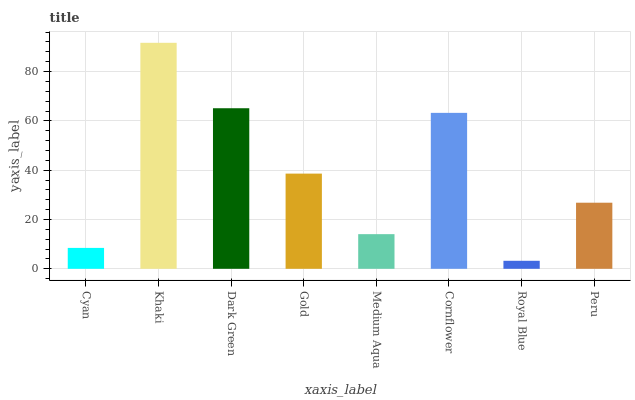Is Royal Blue the minimum?
Answer yes or no. Yes. Is Khaki the maximum?
Answer yes or no. Yes. Is Dark Green the minimum?
Answer yes or no. No. Is Dark Green the maximum?
Answer yes or no. No. Is Khaki greater than Dark Green?
Answer yes or no. Yes. Is Dark Green less than Khaki?
Answer yes or no. Yes. Is Dark Green greater than Khaki?
Answer yes or no. No. Is Khaki less than Dark Green?
Answer yes or no. No. Is Gold the high median?
Answer yes or no. Yes. Is Peru the low median?
Answer yes or no. Yes. Is Peru the high median?
Answer yes or no. No. Is Khaki the low median?
Answer yes or no. No. 